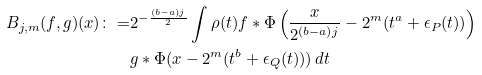Convert formula to latex. <formula><loc_0><loc_0><loc_500><loc_500>B _ { j , m } ( f , g ) ( x ) \colon = & 2 ^ { - \frac { ( b - a ) j } { 2 } } \int \rho ( t ) f * \Phi \left ( \frac { x } { 2 ^ { ( b - a ) j } } - 2 ^ { m } ( t ^ { a } + \epsilon _ { P } ( t ) ) \right ) \\ & g * \Phi ( x - 2 ^ { m } ( t ^ { b } + \epsilon _ { Q } ( t ) ) ) \, d t</formula> 